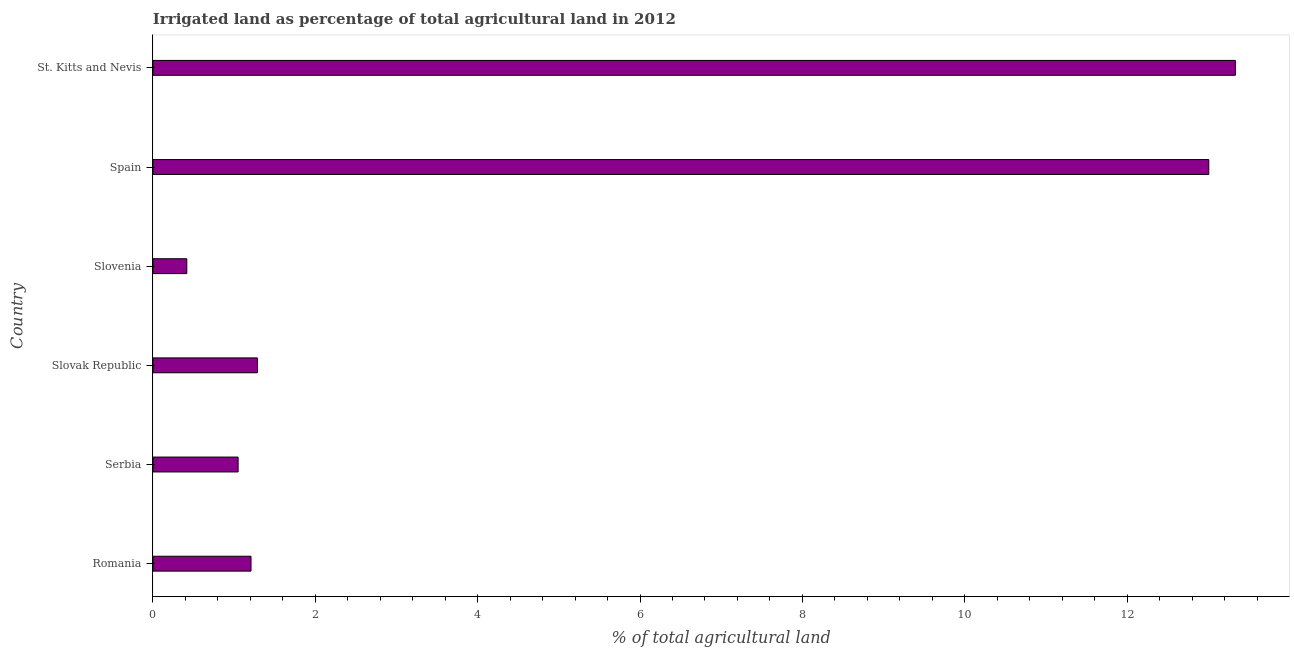Does the graph contain grids?
Provide a short and direct response. No. What is the title of the graph?
Your response must be concise. Irrigated land as percentage of total agricultural land in 2012. What is the label or title of the X-axis?
Provide a short and direct response. % of total agricultural land. What is the label or title of the Y-axis?
Make the answer very short. Country. What is the percentage of agricultural irrigated land in Spain?
Your response must be concise. 13.01. Across all countries, what is the maximum percentage of agricultural irrigated land?
Make the answer very short. 13.33. Across all countries, what is the minimum percentage of agricultural irrigated land?
Provide a succinct answer. 0.42. In which country was the percentage of agricultural irrigated land maximum?
Provide a succinct answer. St. Kitts and Nevis. In which country was the percentage of agricultural irrigated land minimum?
Provide a short and direct response. Slovenia. What is the sum of the percentage of agricultural irrigated land?
Provide a succinct answer. 30.3. What is the difference between the percentage of agricultural irrigated land in Slovenia and Spain?
Your response must be concise. -12.59. What is the average percentage of agricultural irrigated land per country?
Your response must be concise. 5.05. What is the median percentage of agricultural irrigated land?
Your answer should be very brief. 1.25. In how many countries, is the percentage of agricultural irrigated land greater than 1.2 %?
Offer a terse response. 4. What is the ratio of the percentage of agricultural irrigated land in Slovenia to that in St. Kitts and Nevis?
Your answer should be compact. 0.03. Is the percentage of agricultural irrigated land in Serbia less than that in St. Kitts and Nevis?
Provide a short and direct response. Yes. What is the difference between the highest and the second highest percentage of agricultural irrigated land?
Offer a very short reply. 0.33. Is the sum of the percentage of agricultural irrigated land in Romania and Slovenia greater than the maximum percentage of agricultural irrigated land across all countries?
Provide a succinct answer. No. What is the difference between the highest and the lowest percentage of agricultural irrigated land?
Provide a succinct answer. 12.92. In how many countries, is the percentage of agricultural irrigated land greater than the average percentage of agricultural irrigated land taken over all countries?
Make the answer very short. 2. How many bars are there?
Provide a short and direct response. 6. Are all the bars in the graph horizontal?
Your answer should be compact. Yes. How many countries are there in the graph?
Offer a very short reply. 6. What is the difference between two consecutive major ticks on the X-axis?
Offer a terse response. 2. Are the values on the major ticks of X-axis written in scientific E-notation?
Your answer should be compact. No. What is the % of total agricultural land of Romania?
Offer a terse response. 1.21. What is the % of total agricultural land in Serbia?
Offer a very short reply. 1.05. What is the % of total agricultural land in Slovak Republic?
Provide a succinct answer. 1.29. What is the % of total agricultural land of Slovenia?
Make the answer very short. 0.42. What is the % of total agricultural land of Spain?
Provide a short and direct response. 13.01. What is the % of total agricultural land of St. Kitts and Nevis?
Give a very brief answer. 13.33. What is the difference between the % of total agricultural land in Romania and Serbia?
Your answer should be compact. 0.16. What is the difference between the % of total agricultural land in Romania and Slovak Republic?
Make the answer very short. -0.08. What is the difference between the % of total agricultural land in Romania and Slovenia?
Your answer should be very brief. 0.79. What is the difference between the % of total agricultural land in Romania and Spain?
Provide a succinct answer. -11.8. What is the difference between the % of total agricultural land in Romania and St. Kitts and Nevis?
Provide a short and direct response. -12.13. What is the difference between the % of total agricultural land in Serbia and Slovak Republic?
Offer a very short reply. -0.24. What is the difference between the % of total agricultural land in Serbia and Slovenia?
Provide a succinct answer. 0.63. What is the difference between the % of total agricultural land in Serbia and Spain?
Make the answer very short. -11.96. What is the difference between the % of total agricultural land in Serbia and St. Kitts and Nevis?
Give a very brief answer. -12.28. What is the difference between the % of total agricultural land in Slovak Republic and Slovenia?
Your answer should be very brief. 0.87. What is the difference between the % of total agricultural land in Slovak Republic and Spain?
Your answer should be compact. -11.72. What is the difference between the % of total agricultural land in Slovak Republic and St. Kitts and Nevis?
Your answer should be compact. -12.05. What is the difference between the % of total agricultural land in Slovenia and Spain?
Your answer should be compact. -12.59. What is the difference between the % of total agricultural land in Slovenia and St. Kitts and Nevis?
Offer a terse response. -12.92. What is the difference between the % of total agricultural land in Spain and St. Kitts and Nevis?
Your response must be concise. -0.33. What is the ratio of the % of total agricultural land in Romania to that in Serbia?
Your response must be concise. 1.15. What is the ratio of the % of total agricultural land in Romania to that in Slovak Republic?
Provide a succinct answer. 0.94. What is the ratio of the % of total agricultural land in Romania to that in Slovenia?
Your response must be concise. 2.9. What is the ratio of the % of total agricultural land in Romania to that in Spain?
Your answer should be compact. 0.09. What is the ratio of the % of total agricultural land in Romania to that in St. Kitts and Nevis?
Your answer should be very brief. 0.09. What is the ratio of the % of total agricultural land in Serbia to that in Slovak Republic?
Offer a very short reply. 0.81. What is the ratio of the % of total agricultural land in Serbia to that in Slovenia?
Make the answer very short. 2.52. What is the ratio of the % of total agricultural land in Serbia to that in Spain?
Keep it short and to the point. 0.08. What is the ratio of the % of total agricultural land in Serbia to that in St. Kitts and Nevis?
Give a very brief answer. 0.08. What is the ratio of the % of total agricultural land in Slovak Republic to that in Slovenia?
Offer a very short reply. 3.09. What is the ratio of the % of total agricultural land in Slovak Republic to that in Spain?
Your answer should be compact. 0.1. What is the ratio of the % of total agricultural land in Slovak Republic to that in St. Kitts and Nevis?
Ensure brevity in your answer.  0.1. What is the ratio of the % of total agricultural land in Slovenia to that in Spain?
Offer a very short reply. 0.03. What is the ratio of the % of total agricultural land in Slovenia to that in St. Kitts and Nevis?
Offer a very short reply. 0.03. 